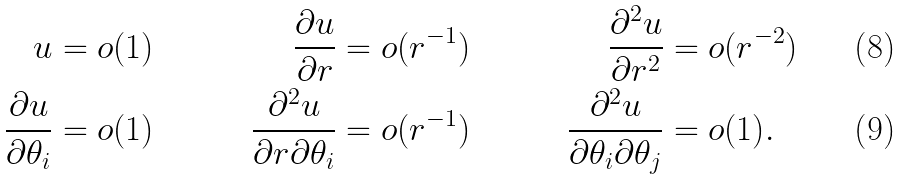<formula> <loc_0><loc_0><loc_500><loc_500>u & = o ( 1 ) & \frac { \partial u } { \partial r } & = o ( r ^ { - 1 } ) & \frac { \partial ^ { 2 } u } { \partial r ^ { 2 } } & = o ( r ^ { - 2 } ) \\ \frac { \partial u } { \partial \theta _ { i } } & = o ( 1 ) & \frac { \partial ^ { 2 } u } { \partial r \partial \theta _ { i } } & = o ( r ^ { - 1 } ) & \frac { \partial ^ { 2 } u } { \partial \theta _ { i } \partial \theta _ { j } } & = o ( 1 ) .</formula> 